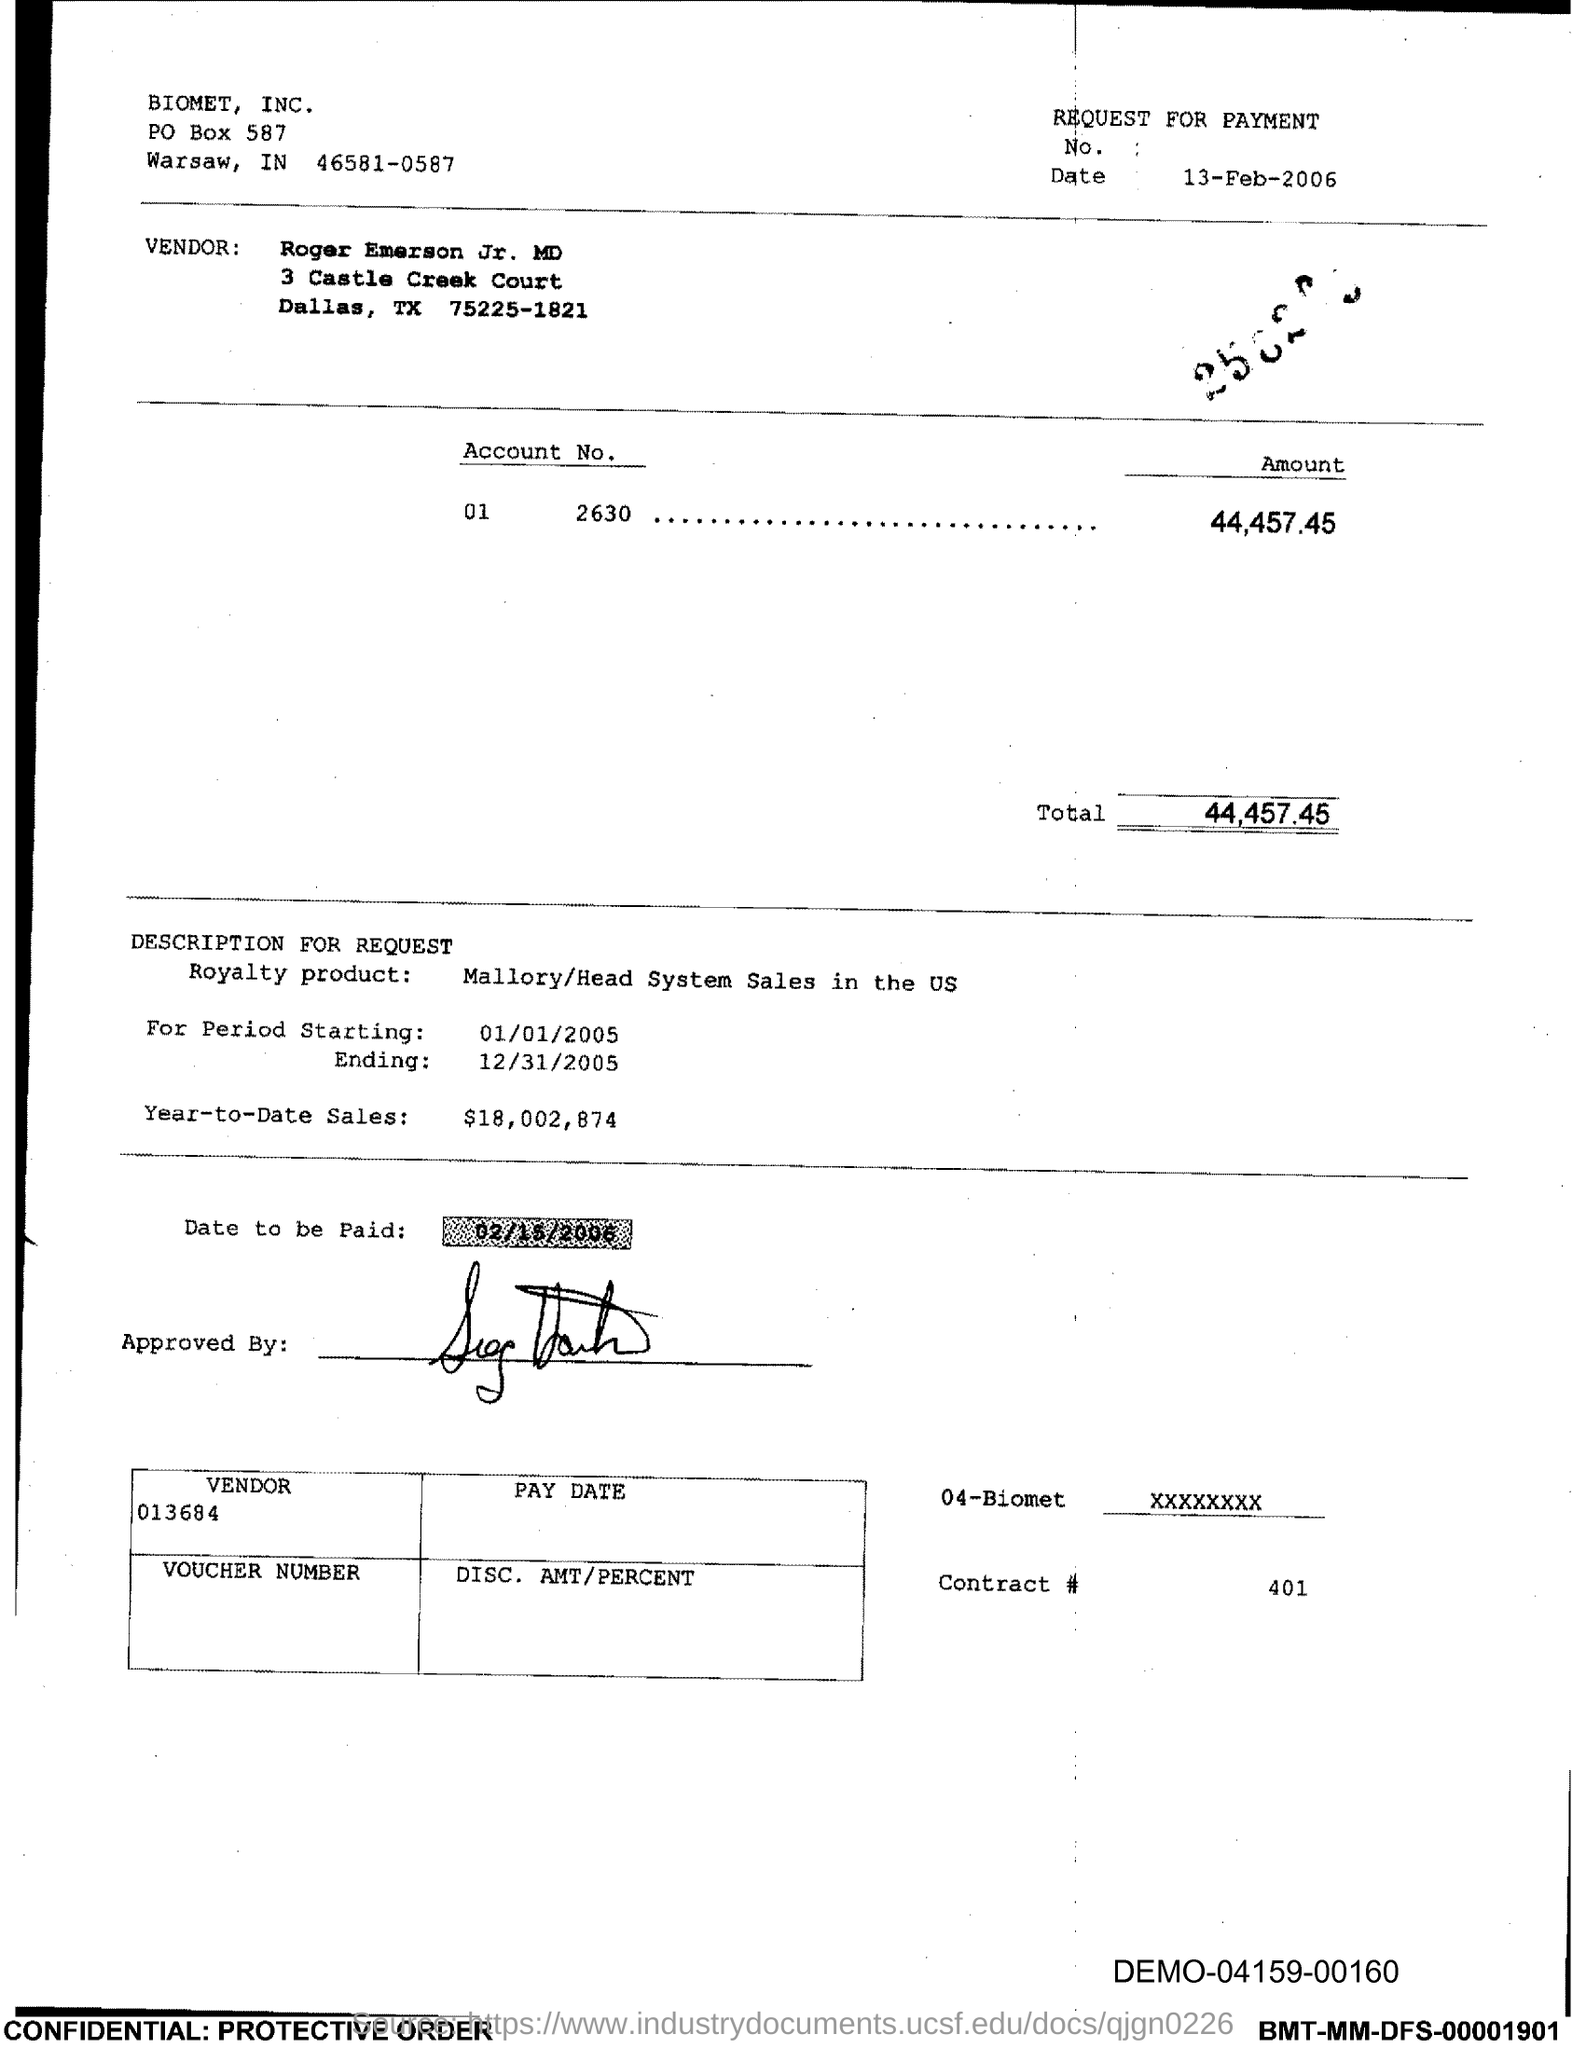What is the PO Box Number mentioned in the document?
Make the answer very short. 587. What is the Total?
Your response must be concise. 44,457.45. What is the Contract # Number?
Provide a short and direct response. 401. 